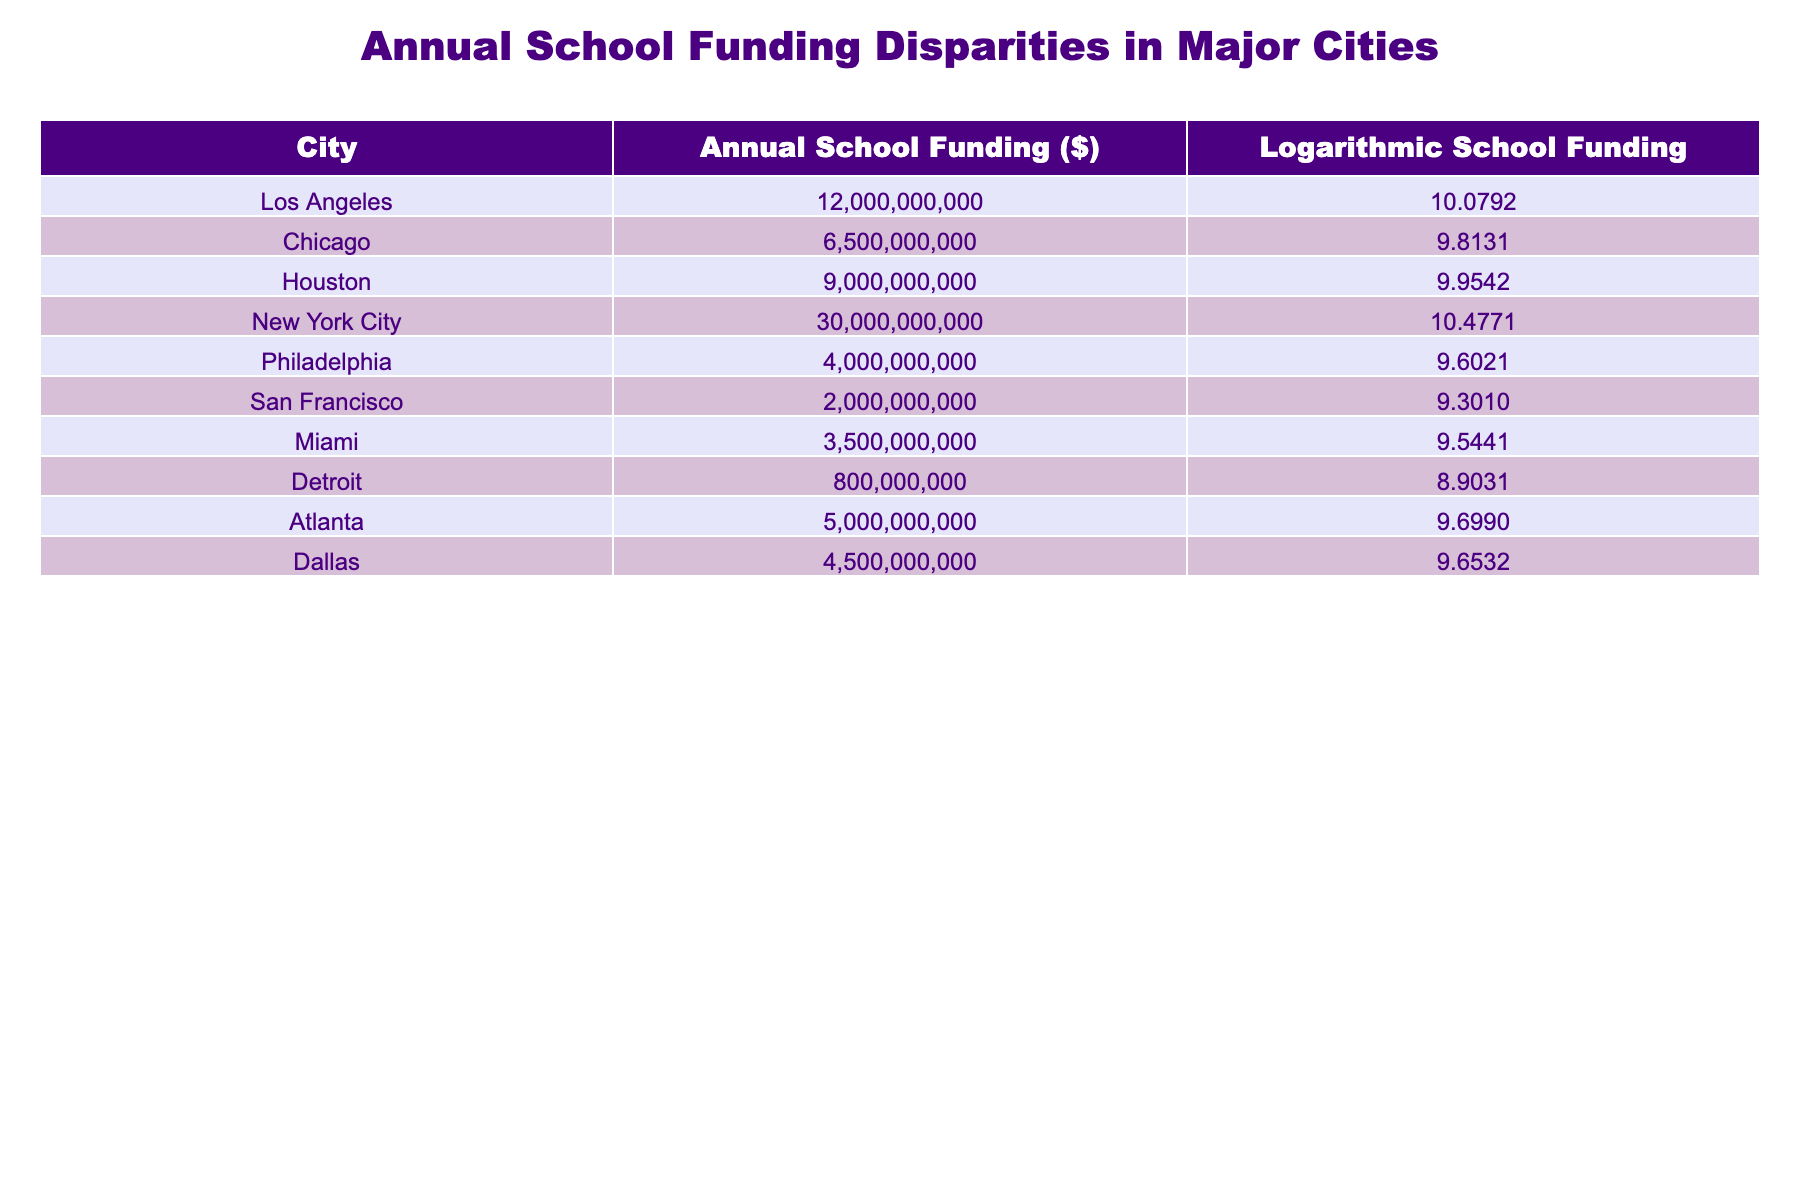What is the annual school funding for New York City? The table lists New York City's annual school funding as $30,000,000,000.
Answer: 30000000000 Which city has the lowest annual school funding? By examining the table, Detroit has the lowest annual school funding at $800,000,000.
Answer: 800000000 What is the difference in annual school funding between Los Angeles and Chicago? The funding for Los Angeles is $12,000,000,000, and for Chicago, it is $6,500,000,000. The difference is $12,000,000,000 - $6,500,000,000 = $5,500,000,000.
Answer: 5500000000 How many cities have annual school funding greater than $10 billion? The cities with funding greater than $10 billion are New York City and Los Angeles. This gives us a total of 2 cities.
Answer: 2 Is the logarithmic school funding for Philadelphia greater than that for San Francisco? The logarithmic values are 9.6021 for Philadelphia and 9.3010 for San Francisco. Since 9.6021 is greater than 9.3010, the statement is true.
Answer: Yes What is the average annual school funding for the cities listed in the table? To find the average, sum the funding amounts: 12 billion (Los Angeles) + 6.5 billion (Chicago) + 9 billion (Houston) + 30 billion (New York City) + 4 billion (Philadelphia) + 2 billion (San Francisco) + 3.5 billion (Miami) + 0.8 billion (Detroit) + 5 billion (Atlanta) + 4.5 billion (Dallas) = 77.8 billion. Then divide by 10 (the number of cities), giving an average of 7.78 billion.
Answer: 7780000000 Which city has a logarithmic school funding value closest to that of Atlanta? Atlanta has a logarithmic funding value of 9.6990. The city with the closest value is Dallas, which is 9.6532, differing by 0.0458.
Answer: Dallas How many cities have logarithmic school funding values below 9.5? The cities with logarithmic funding below 9.5 are Philadelphia (9.6021), San Francisco (9.3010), Miami (9.5441), and Detroit (8.9031), totaling 2 cities below the threshold.
Answer: 2 